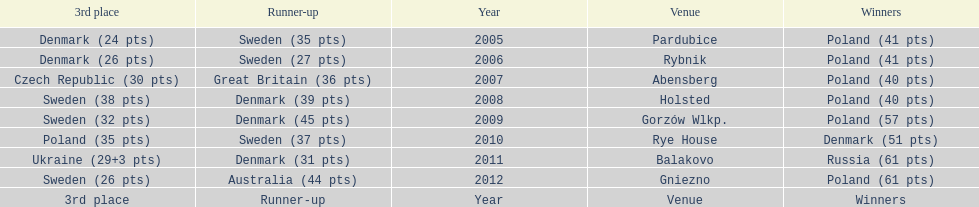When was the first year that poland did not place in the top three positions of the team speedway junior world championship? 2011. 